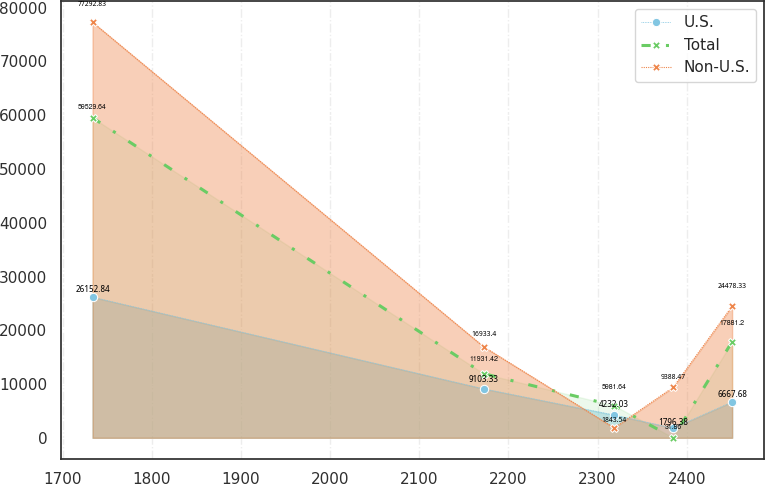Convert chart. <chart><loc_0><loc_0><loc_500><loc_500><line_chart><ecel><fcel>U.S.<fcel>Total<fcel>Non-U.S.<nl><fcel>1733.67<fcel>26152.8<fcel>59529.6<fcel>77292.8<nl><fcel>2172.16<fcel>9103.33<fcel>11931.4<fcel>16933.4<nl><fcel>2318.58<fcel>4232.03<fcel>5981.64<fcel>1843.54<nl><fcel>2384.67<fcel>1796.38<fcel>31.86<fcel>9388.47<nl><fcel>2450.76<fcel>6667.68<fcel>17881.2<fcel>24478.3<nl></chart> 